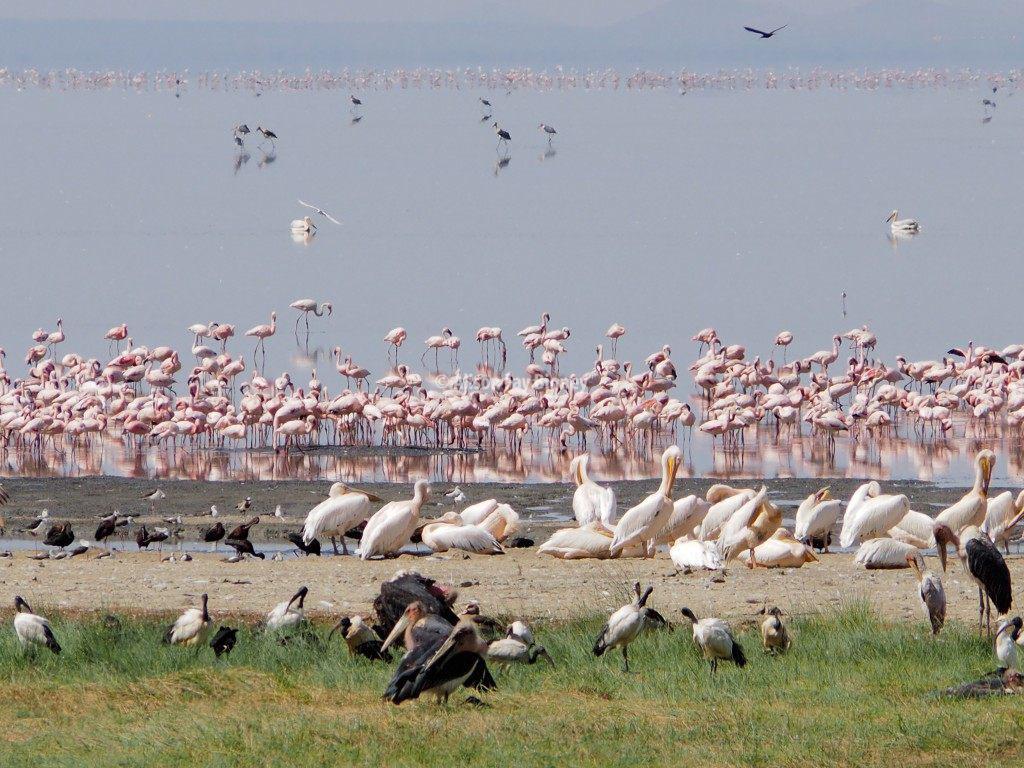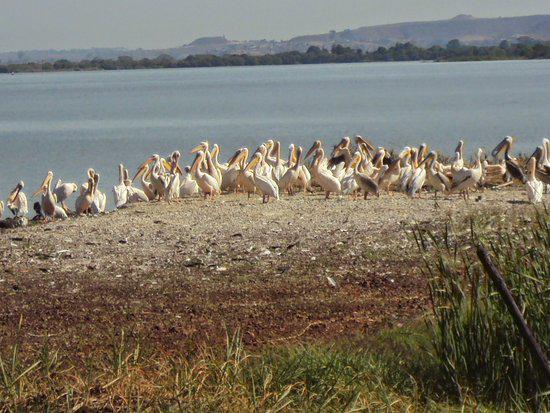The first image is the image on the left, the second image is the image on the right. For the images displayed, is the sentence "The image on the right contains an animal that is not a bird." factually correct? Answer yes or no. No. The first image is the image on the left, the second image is the image on the right. For the images displayed, is the sentence "There is at least one picture where water is not visible." factually correct? Answer yes or no. No. 